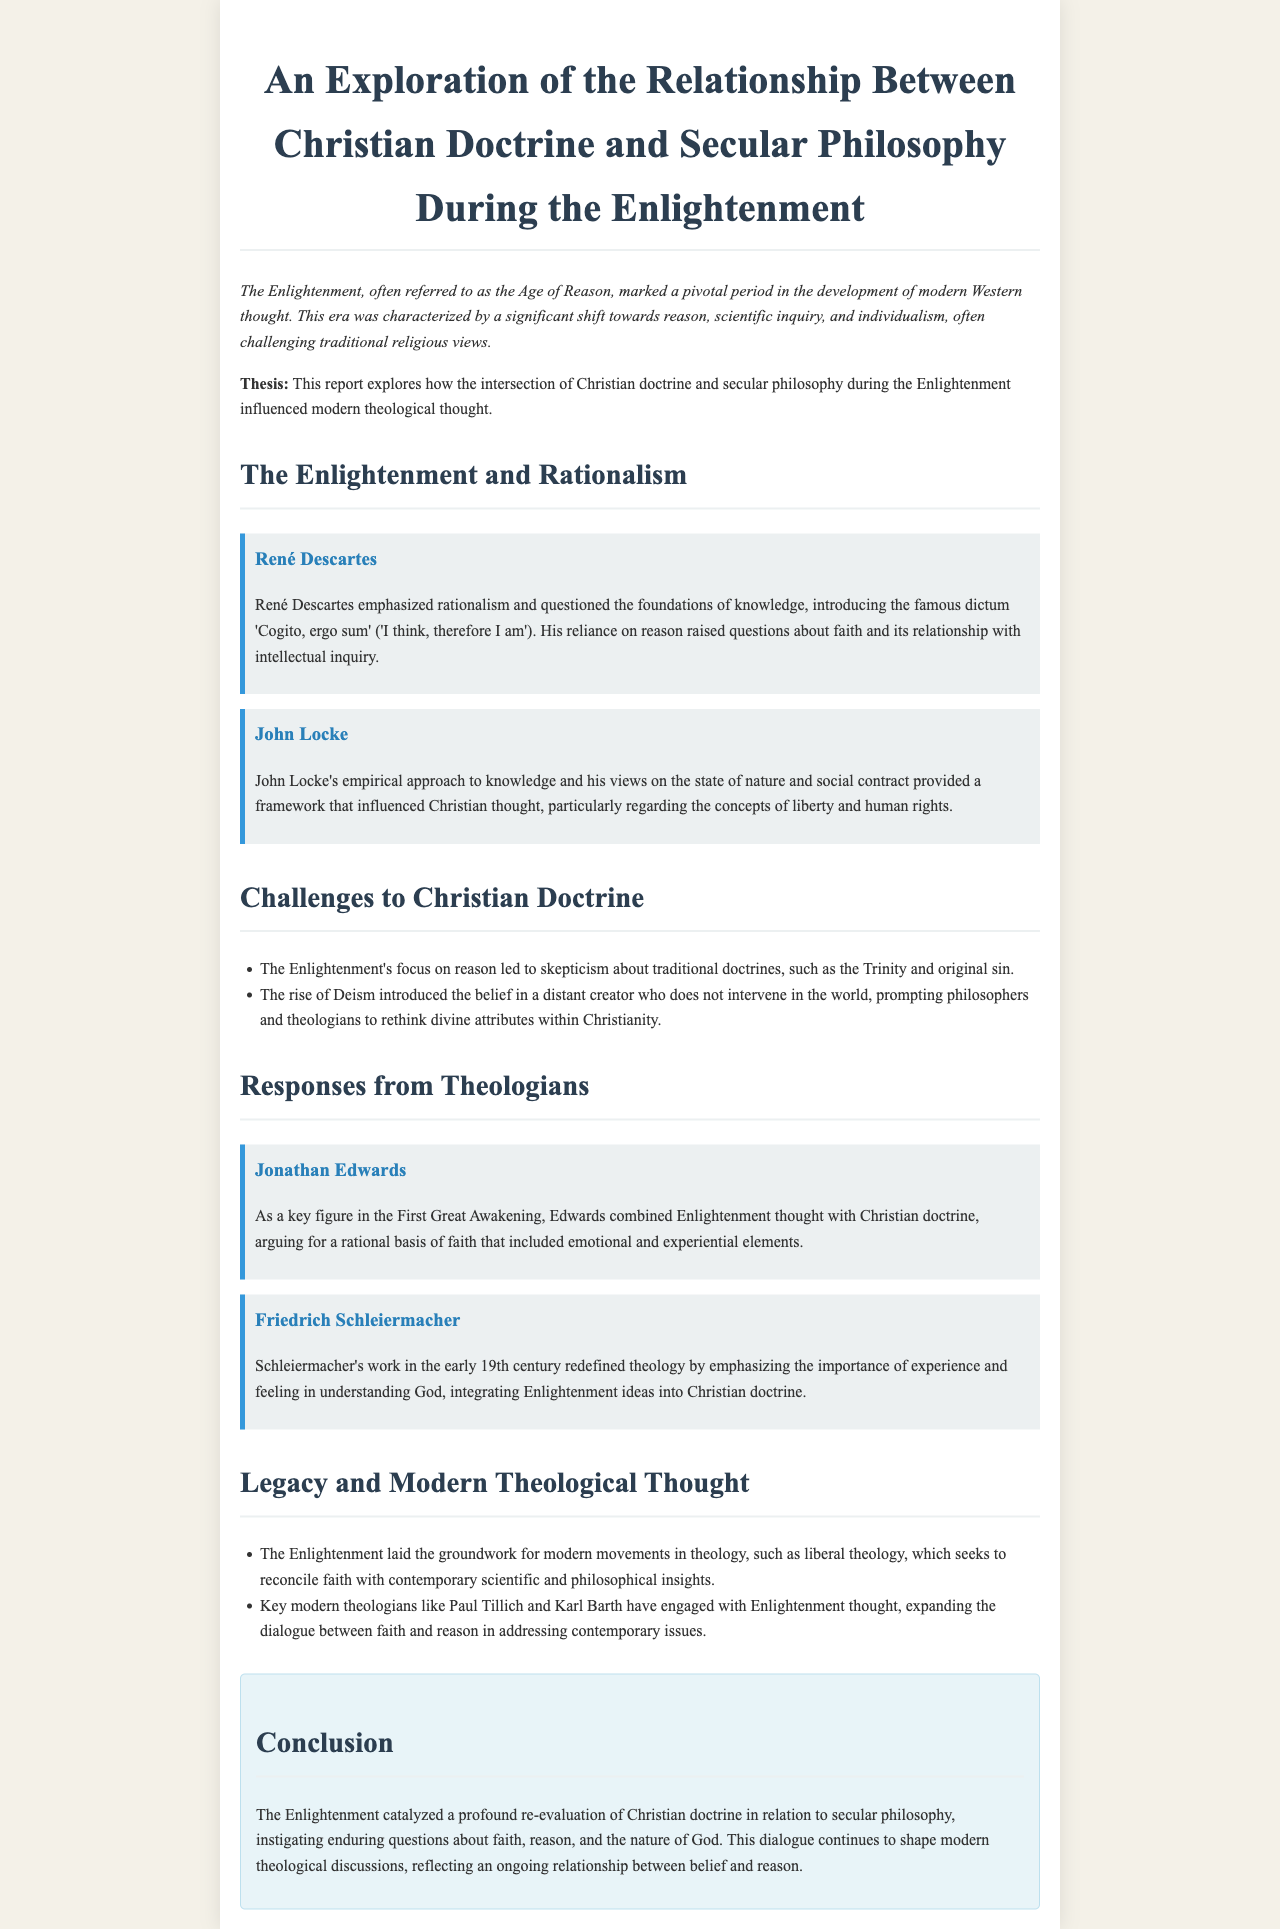What period is referred to as the Age of Reason? The document mentions the Enlightenment as the pivotal period known as the Age of Reason.
Answer: Enlightenment Who introduced the dictum 'Cogito, ergo sum'? The report highlights René Descartes as the figure who introduced this famous dictum.
Answer: René Descartes What did John Locke's views influence in Christian thought? It mentions that John Locke's views influenced the concepts of liberty and human rights in Christian thought.
Answer: Liberty and human rights Which theological response is associated with the First Great Awakening? The document states that Jonathan Edwards is associated with the First Great Awakening.
Answer: Jonathan Edwards What was a key feature of Friedrich Schleiermacher's work? The report notes that Schleiermacher emphasized the importance of experience and feeling in understanding God.
Answer: Experience and feeling Which theological movement seeks to reconcile faith with contemporary insights? The document mentions that liberal theology seeks to reconcile faith with contemporary scientific and philosophical insights.
Answer: Liberal theology What type of philosophy led to skepticism about traditional doctrines? The report indicates that the Enlightenment's focus on reason led to this skepticism.
Answer: Reason What is the primary conclusion drawn in the document? The document concludes that the Enlightenment instigated enduring questions about faith, reason, and the nature of God.
Answer: Enduring questions about faith, reason, and the nature of God 